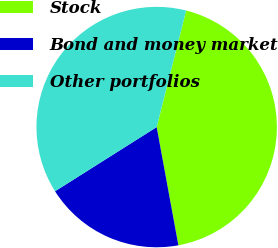<chart> <loc_0><loc_0><loc_500><loc_500><pie_chart><fcel>Stock<fcel>Bond and money market<fcel>Other portfolios<nl><fcel>43.17%<fcel>18.92%<fcel>37.91%<nl></chart> 